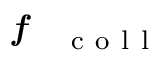<formula> <loc_0><loc_0><loc_500><loc_500>f _ { c o l l }</formula> 